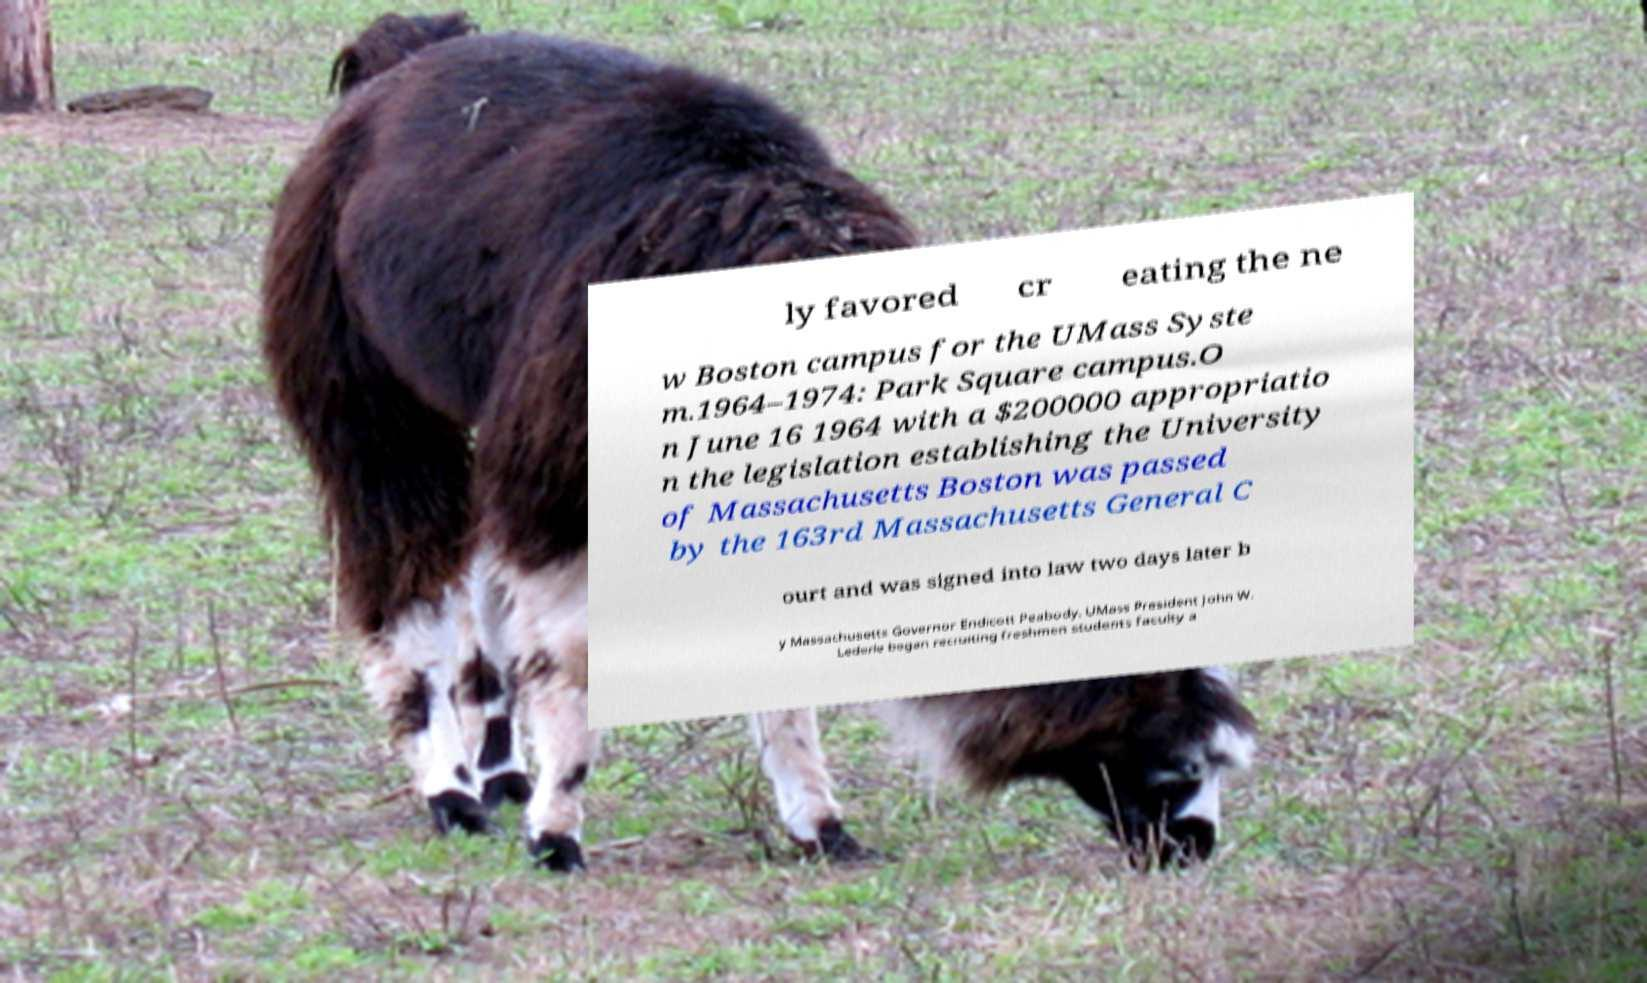There's text embedded in this image that I need extracted. Can you transcribe it verbatim? ly favored cr eating the ne w Boston campus for the UMass Syste m.1964–1974: Park Square campus.O n June 16 1964 with a $200000 appropriatio n the legislation establishing the University of Massachusetts Boston was passed by the 163rd Massachusetts General C ourt and was signed into law two days later b y Massachusetts Governor Endicott Peabody. UMass President John W. Lederle began recruiting freshmen students faculty a 